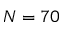<formula> <loc_0><loc_0><loc_500><loc_500>N = 7 0</formula> 